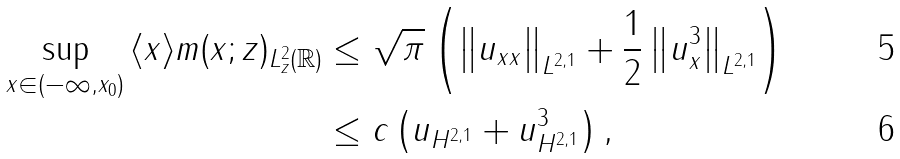<formula> <loc_0><loc_0><loc_500><loc_500>\sup _ { x \in \left ( - \infty , x _ { 0 } \right ) } \| \langle x \rangle m ( x ; z ) \| _ { L _ { z } ^ { 2 } ( \mathbb { R } ) } & \leq \sqrt { \pi } \left ( \left \| u _ { x x } \right \| _ { L ^ { 2 , 1 } } + \frac { 1 } { 2 } \left \| u _ { x } ^ { 3 } \right \| _ { L ^ { 2 , 1 } } \right ) \\ & \leq c \left ( \| u \| _ { H ^ { 2 , 1 } } + \| u \| _ { H ^ { 2 , 1 } } ^ { 3 } \right ) ,</formula> 